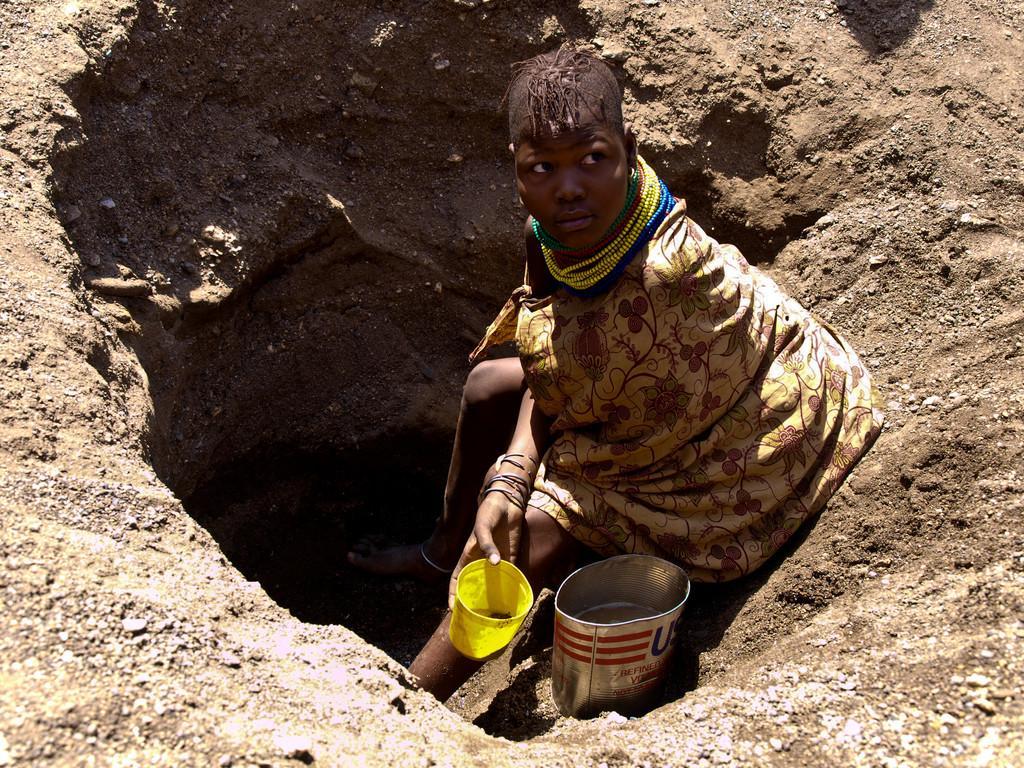Can you describe this image briefly? In this image we can see a person wearing dress is holding a green color objects and standing inside the dig. 